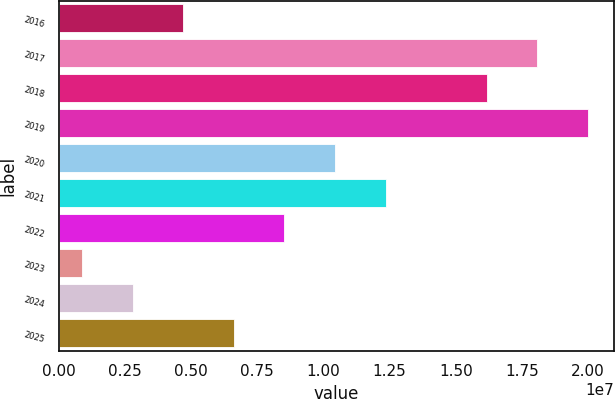Convert chart. <chart><loc_0><loc_0><loc_500><loc_500><bar_chart><fcel>2016<fcel>2017<fcel>2018<fcel>2019<fcel>2020<fcel>2021<fcel>2022<fcel>2023<fcel>2024<fcel>2025<nl><fcel>4.7052e+06<fcel>1.80759e+07<fcel>1.61658e+07<fcel>1.9986e+07<fcel>1.04355e+07<fcel>1.23456e+07<fcel>8.5254e+06<fcel>885000<fcel>2.7951e+06<fcel>6.6153e+06<nl></chart> 